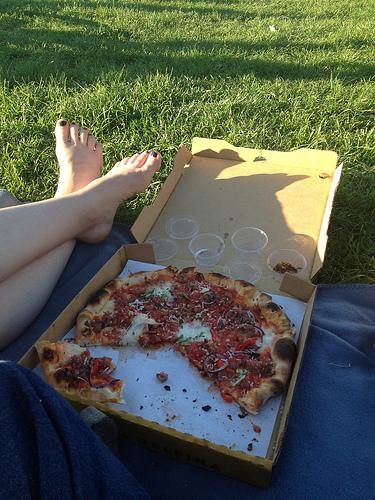Describe the person's visible body features in the image. A female's legs and feet are visible, with black nail polish on her toenails, and her knees covered in denim. Write a brief summary of the items found in the image. The image includes a half-eaten pizza, plastic containers, a blue blanket, green grass, and a woman's legs with painted toenails. Describe the situational details and the subject's visible features in the image. The woman with dark painted toenails is relishing a partially eaten pizza with red onion slices at an outdoor picnic on a blue blanket. Describe the setting in which the main subject is found. The partially eaten pizza is set on a blue picnic blanket in a grassy area with the person's legs in view, showcasing painted toenails. Provide a concise description of the scene in the image. A picnic scene with a lady eating pizza on a blue blanket, showing her painted toenails, amidst a grassy field. Provide a brief overview of the scene in the image. A woman with painted toenails is enjoying a half-eaten pizza with various toppings on a blue picnic blanket in a grassy field. Explain the leisure activity that is occurring in the image. A female is having a pizza picnic on a blue blanket while displaying her painted toenails, set on a grassy outdoor field. Mention the major components of the image. The image features a female's legs, partially eaten pizza, empty plastic containers, blue blanket, and the green grass field. Write a short statement about the main activity in the image. A person is having pizza on a blue blanket laid on a grassy field, with painted toenails visible. Explain the condition of the pizza, and what's on it besides toppings. The pizza is half eaten, with well-browned crust, red onion slices, and empty plastic containers for additional toppings. 